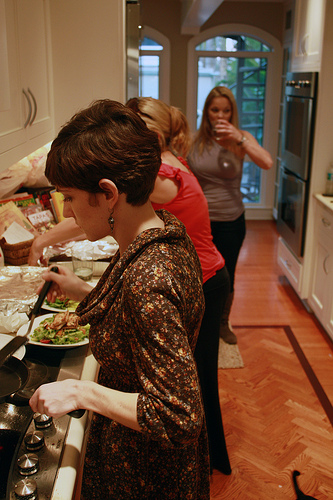Please provide a short description for this region: [0.53, 0.25, 0.68, 0.47]. Woman has gray shirt. This region highlights a woman wearing a gray shirt. 